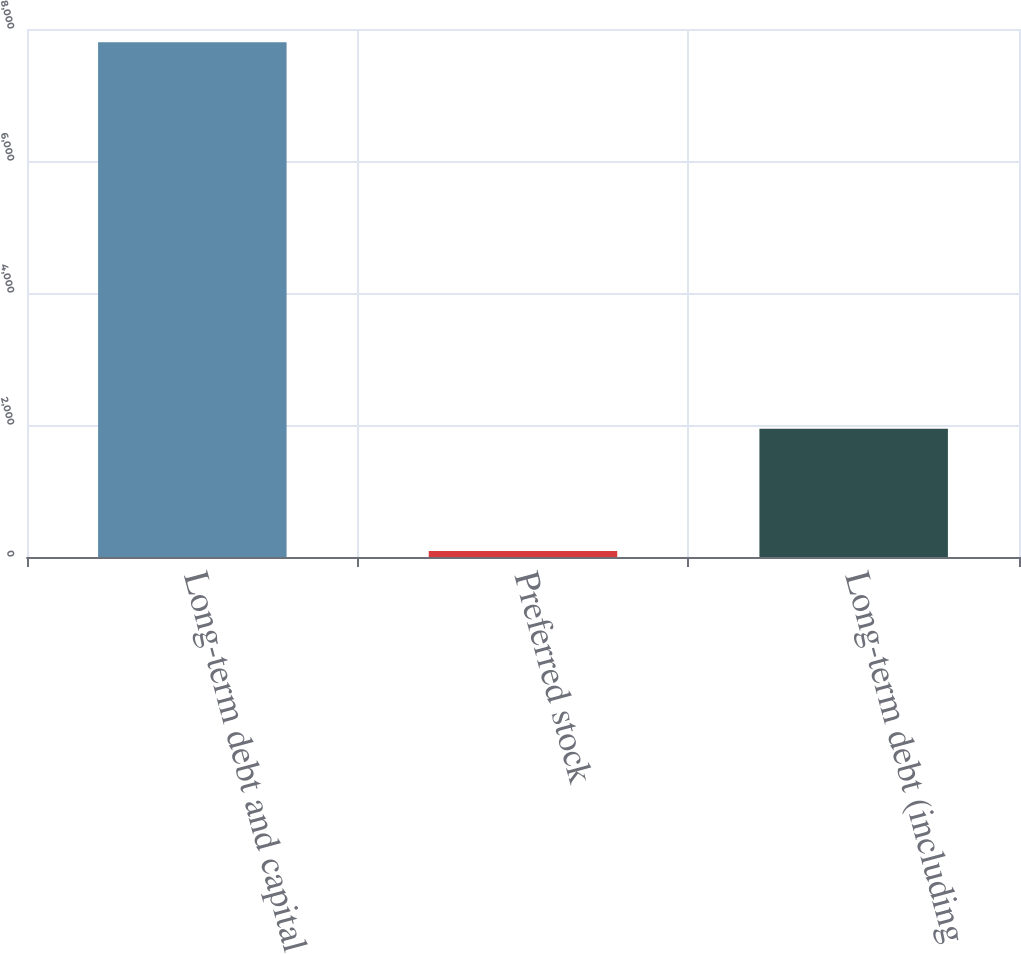Convert chart. <chart><loc_0><loc_0><loc_500><loc_500><bar_chart><fcel>Long-term debt and capital<fcel>Preferred stock<fcel>Long-term debt (including<nl><fcel>7800<fcel>92<fcel>1943<nl></chart> 